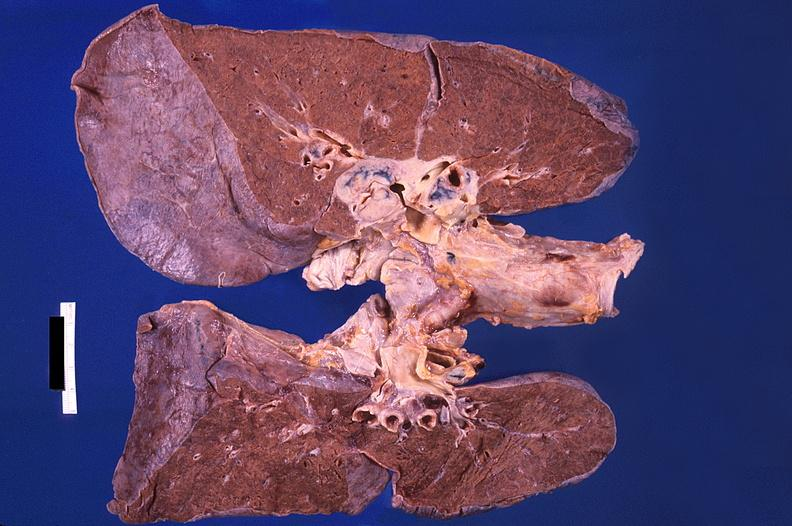what is present?
Answer the question using a single word or phrase. Respiratory 